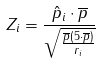Convert formula to latex. <formula><loc_0><loc_0><loc_500><loc_500>Z _ { i } = \frac { \hat { p } _ { i } \cdot \overline { p } } { \sqrt { \frac { \overline { p } ( 5 \cdot \overline { p } ) } { r _ { i } } } }</formula> 